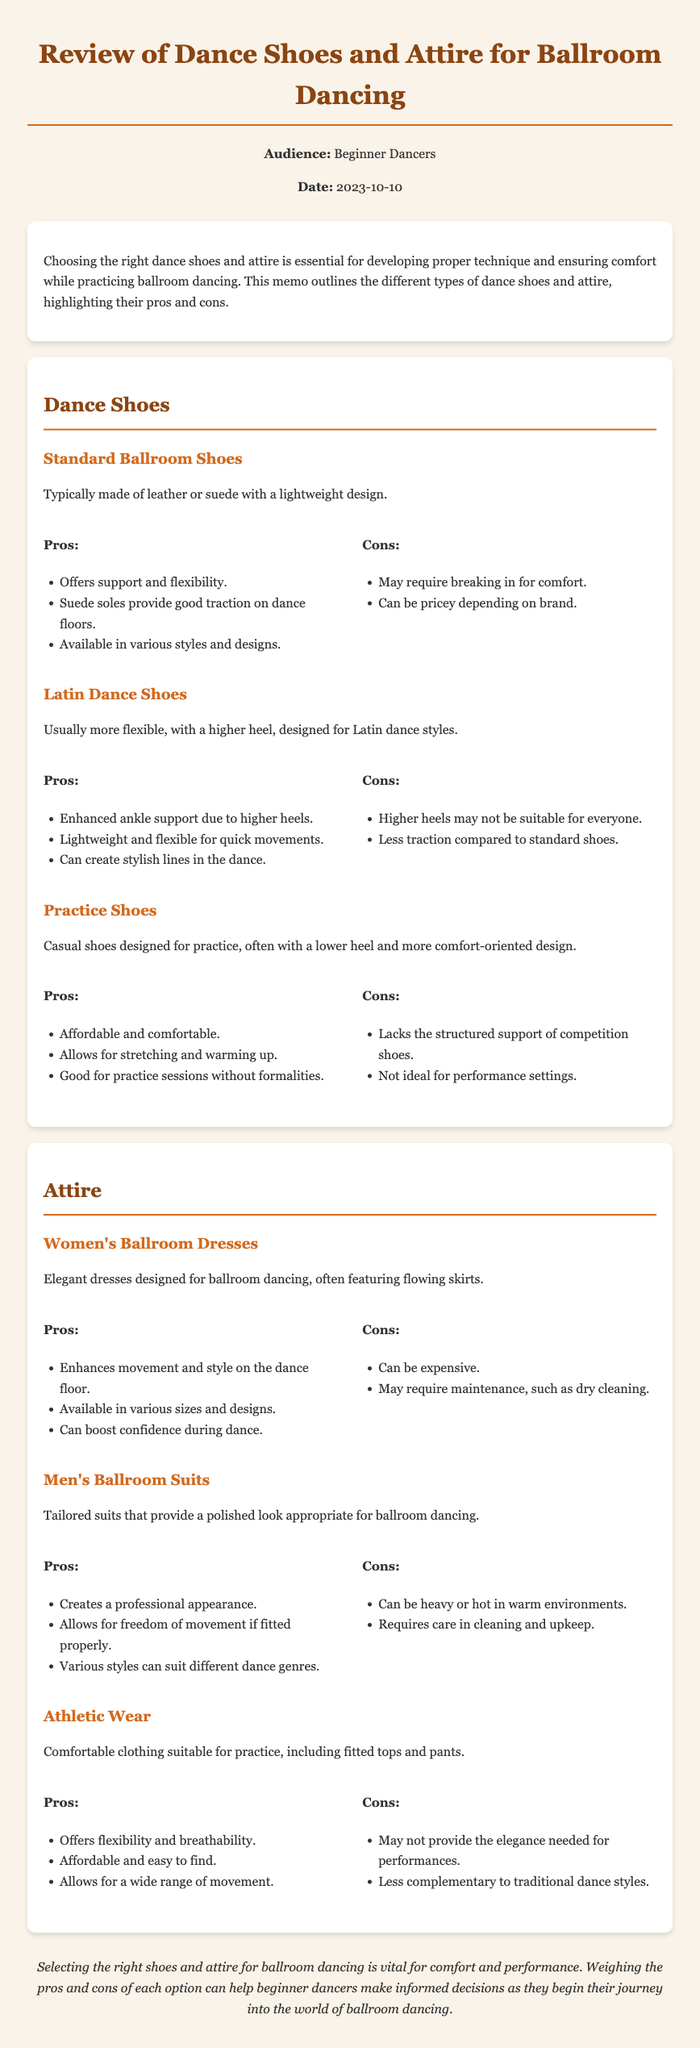What are the three types of dance shoes mentioned? The memo lists three types of dance shoes: Standard Ballroom Shoes, Latin Dance Shoes, and Practice Shoes.
Answer: Standard Ballroom Shoes, Latin Dance Shoes, Practice Shoes What is one pro of Standard Ballroom Shoes? The memo states that one pro of Standard Ballroom Shoes is that they offer support and flexibility.
Answer: Offers support and flexibility What is one con of Latin Dance Shoes? The document mentions that a con of Latin Dance Shoes is that higher heels may not be suitable for everyone.
Answer: Higher heels may not be suitable for everyone What is the design focus of women's ballroom dresses? According to the memo, women's ballroom dresses are designed to enhance movement and style on the dance floor.
Answer: Enhance movement and style What is a reason someone might choose practice shoes? The document states that practice shoes are affordable and comfortable, allowing for stretching and warming up.
Answer: Affordable and comfortable What is the main purpose of the memo? The memo aims to aid beginner dancers in making informed choices about dance shoes and attire.
Answer: Aid beginner dancers What type of attire may not provide elegance for performances? The memo mentions that athletic wear may not provide the elegance needed for performances.
Answer: Athletic wear 